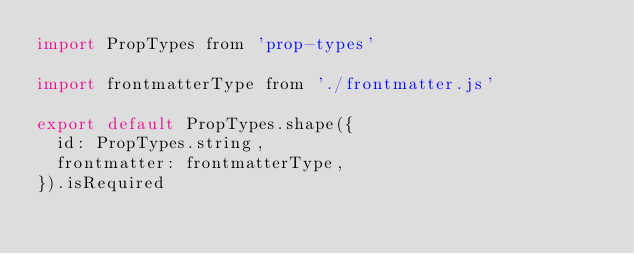<code> <loc_0><loc_0><loc_500><loc_500><_JavaScript_>import PropTypes from 'prop-types'

import frontmatterType from './frontmatter.js'

export default PropTypes.shape({
  id: PropTypes.string,
  frontmatter: frontmatterType,
}).isRequired
</code> 